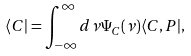<formula> <loc_0><loc_0><loc_500><loc_500>\langle C | = \int _ { - \infty } ^ { \infty } d \nu \Psi _ { C } ( \nu ) \langle C , P | ,</formula> 